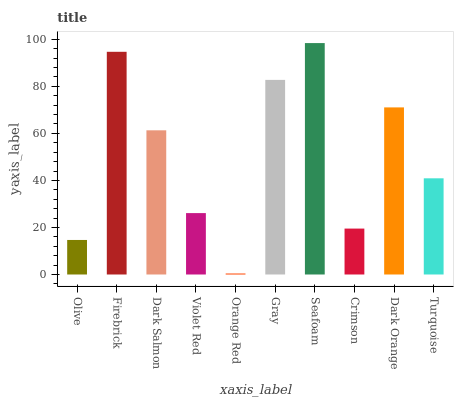Is Orange Red the minimum?
Answer yes or no. Yes. Is Seafoam the maximum?
Answer yes or no. Yes. Is Firebrick the minimum?
Answer yes or no. No. Is Firebrick the maximum?
Answer yes or no. No. Is Firebrick greater than Olive?
Answer yes or no. Yes. Is Olive less than Firebrick?
Answer yes or no. Yes. Is Olive greater than Firebrick?
Answer yes or no. No. Is Firebrick less than Olive?
Answer yes or no. No. Is Dark Salmon the high median?
Answer yes or no. Yes. Is Turquoise the low median?
Answer yes or no. Yes. Is Gray the high median?
Answer yes or no. No. Is Dark Salmon the low median?
Answer yes or no. No. 